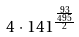Convert formula to latex. <formula><loc_0><loc_0><loc_500><loc_500>4 \cdot 1 4 1 ^ { \frac { \frac { 9 3 } { 4 9 5 } } { 2 } }</formula> 